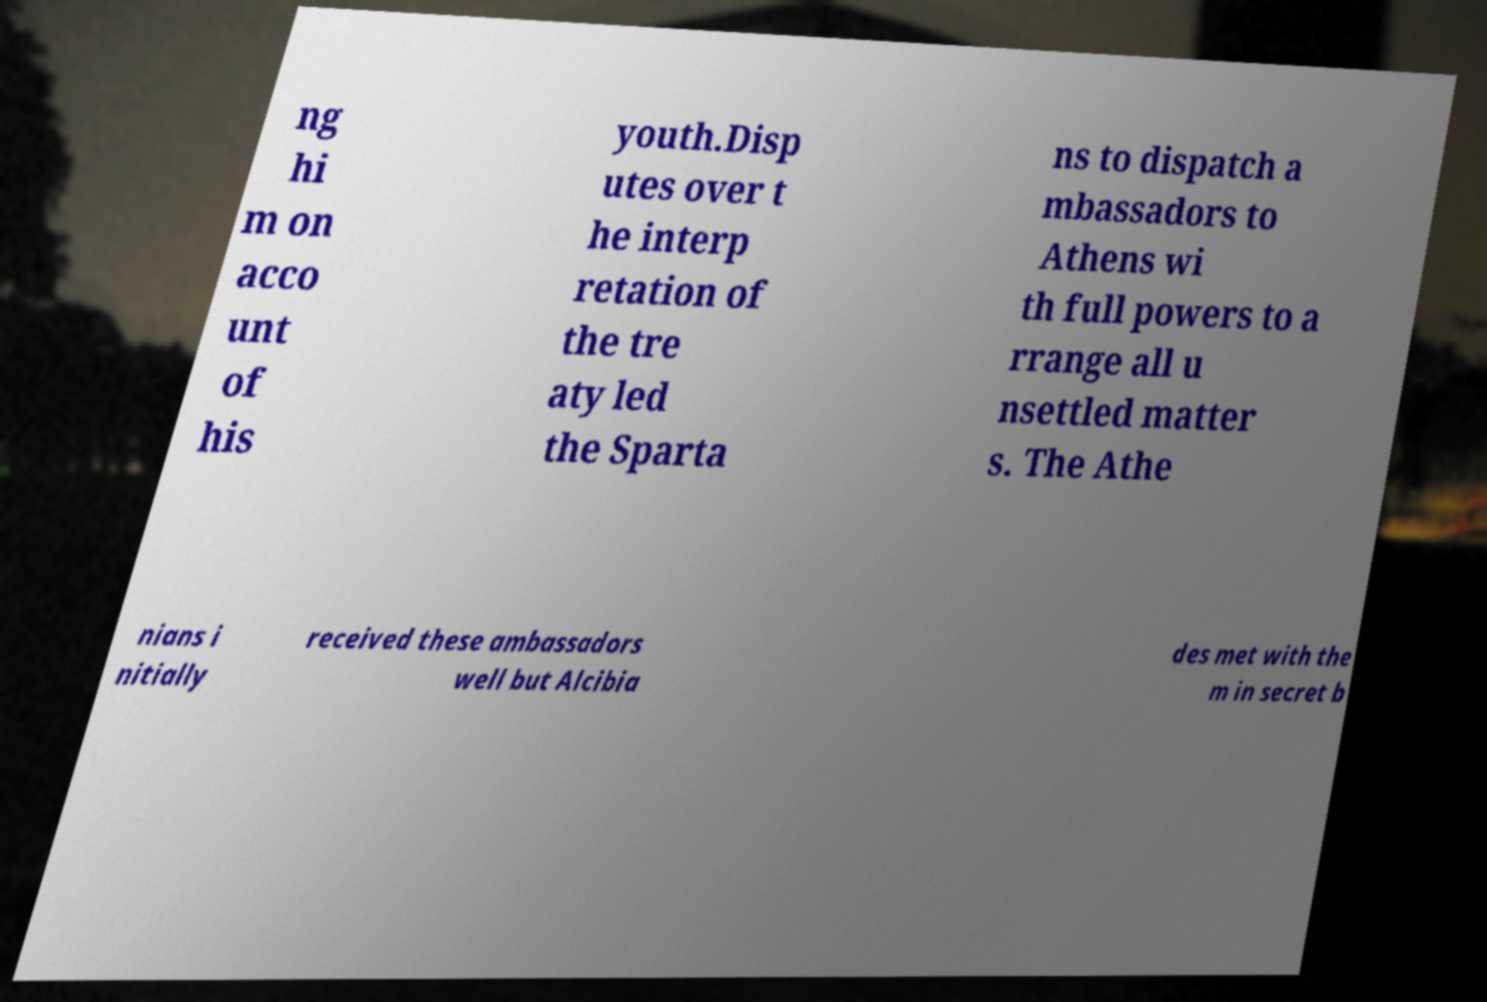I need the written content from this picture converted into text. Can you do that? ng hi m on acco unt of his youth.Disp utes over t he interp retation of the tre aty led the Sparta ns to dispatch a mbassadors to Athens wi th full powers to a rrange all u nsettled matter s. The Athe nians i nitially received these ambassadors well but Alcibia des met with the m in secret b 